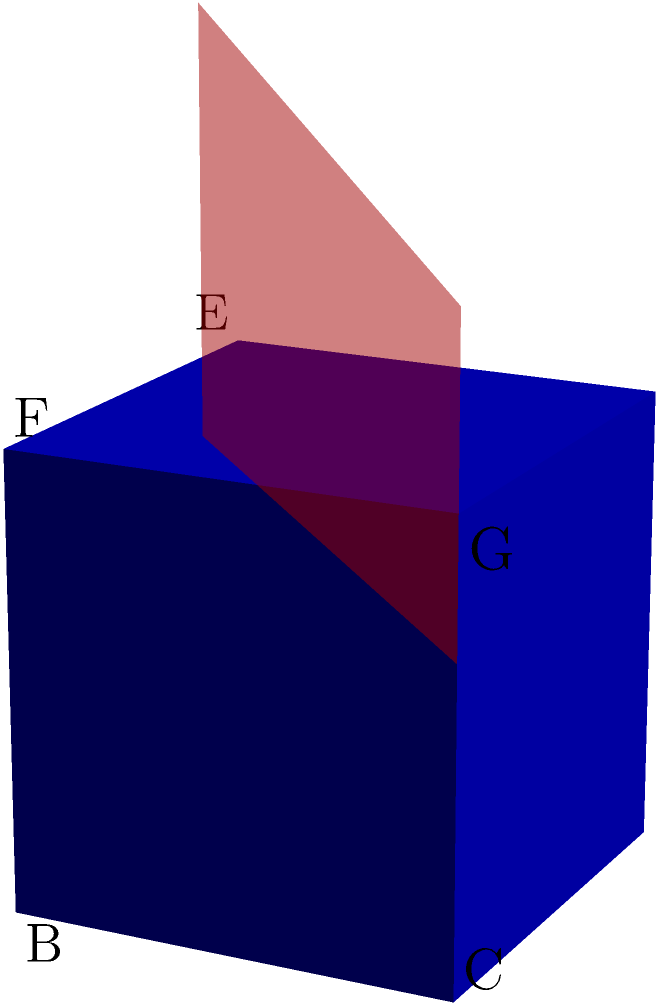As part of a STEM curriculum designed to enhance spatial reasoning skills for future engineering and technology careers, consider the cube ABCDEFGH shown above. A plane intersects the cube parallel to face ABCD at a height of 0.7 units from the base. What shape is formed by this intersection, and what are its dimensions? To solve this problem, let's follow these steps:

1. Understand the given information:
   - We have a unit cube (side length = 1 unit)
   - The cutting plane is parallel to face ABCD
   - The plane is 0.7 units above the base

2. Determine the shape of the intersection:
   - Since the cutting plane is parallel to face ABCD, the intersection will be a rectangle (as it's a scaled version of the base)

3. Calculate the dimensions of the rectangle:
   - The width and length of the rectangle will be equal to the side length of the cube
   - Width = Length = 1 unit

4. Consider the implications for STEM education:
   - This exercise demonstrates the importance of spatial reasoning in engineering and technology
   - It connects abstract mathematical concepts to real-world applications in fields like computer-aided design and 3D modeling

5. Relate to industry needs:
   - Proficiency in visualizing cross-sections is crucial for careers in architecture, manufacturing, and medical imaging

Therefore, the intersection formed is a square (a special case of a rectangle where all sides are equal) with dimensions 1 unit by 1 unit.
Answer: A square with side length 1 unit 